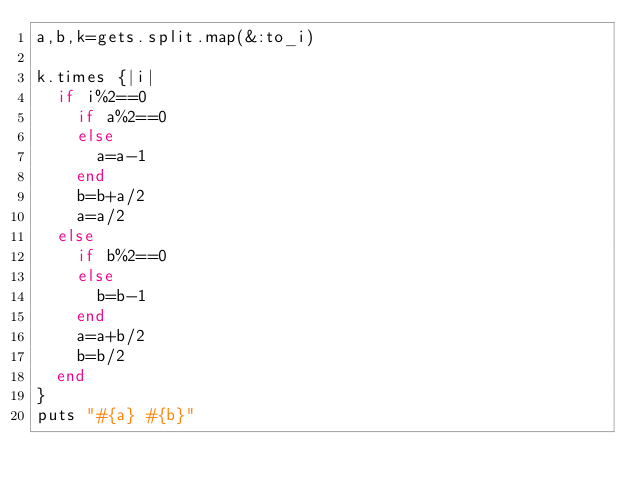<code> <loc_0><loc_0><loc_500><loc_500><_Ruby_>a,b,k=gets.split.map(&:to_i)

k.times {|i|
  if i%2==0
    if a%2==0
    else
      a=a-1
    end
    b=b+a/2
    a=a/2
  else
    if b%2==0
    else
      b=b-1
    end
    a=a+b/2
    b=b/2
  end
}
puts "#{a} #{b}"
</code> 